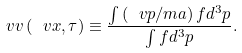Convert formula to latex. <formula><loc_0><loc_0><loc_500><loc_500>\ v v \left ( \ v x , \tau \right ) \equiv \frac { \int \left ( \ v p / m a \right ) f d ^ { 3 } p } { \int f d ^ { 3 } p } .</formula> 